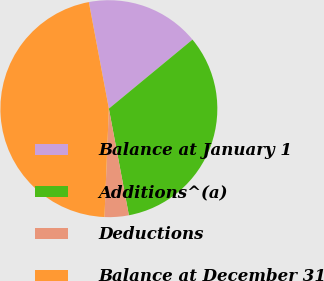Convert chart to OTSL. <chart><loc_0><loc_0><loc_500><loc_500><pie_chart><fcel>Balance at January 1<fcel>Additions^(a)<fcel>Deductions<fcel>Balance at December 31<nl><fcel>16.97%<fcel>33.03%<fcel>3.6%<fcel>46.4%<nl></chart> 